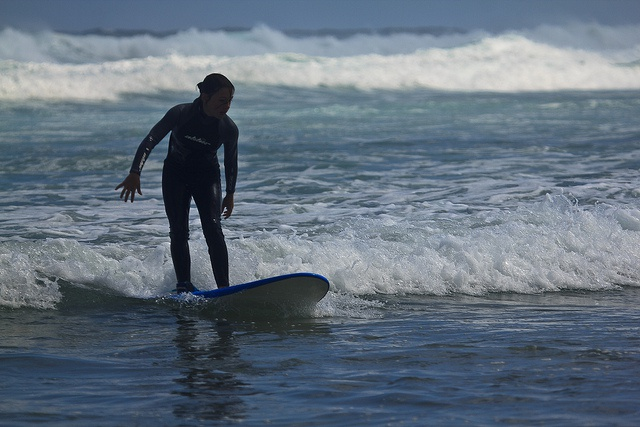Describe the objects in this image and their specific colors. I can see people in gray, black, and darkgray tones and surfboard in gray, black, navy, and darkblue tones in this image. 